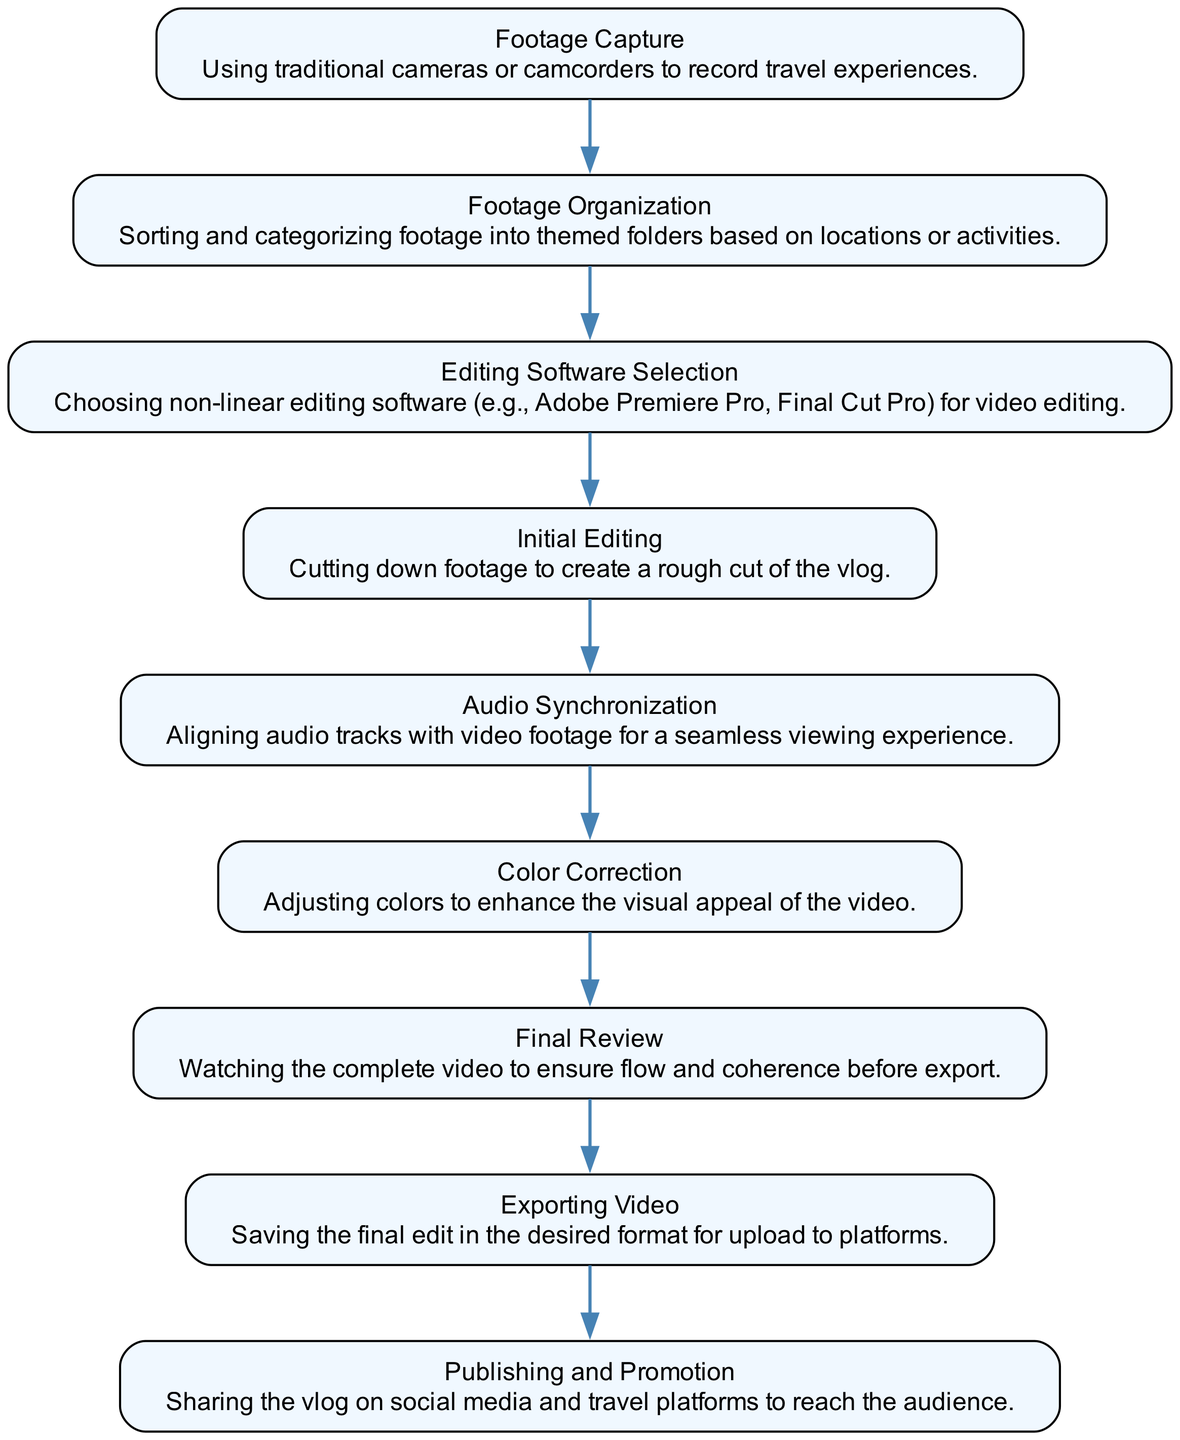What is the first step in the traditional editing process? The first step in the diagram is "Footage Capture," which indicates that recording travel experiences is the initial action taken.
Answer: Footage Capture How many main steps are there in the traditional editing process shown in the diagram? By counting each node within the diagram, we find that there are a total of nine main steps represented.
Answer: Nine Which step comes after "Initial Editing"? After "Initial Editing," the next step indicated in the flow is "Audio Synchronization," showing the sequential progression.
Answer: Audio Synchronization What type of software is selected in the editing process? The diagram specifies "non-linear editing software" as the type of software used, indicating a specific category of editing tools.
Answer: Non-linear editing software Which process is last before exporting the video? Before the video gets exported, the "Final Review" step takes place, highlighting the importance of ensuring quality and coherence.
Answer: Final Review What activity follows after the "Exporting Video" step? Following the exportation of the video, the "Publishing and Promotion" step occurs, emphasizing the sharing of the vlog with an audience.
Answer: Publishing and Promotion Which two steps focus on enhancing the video's quality? The steps "Color Correction" and "Audio Synchronization" both aim to enhance the overall quality of the video, addressing visual appeal and audio clarity.
Answer: Color Correction and Audio Synchronization What is the main purpose of the "Footage Organization" step? The purpose of "Footage Organization" is to sort and categorize footage into themed folders, facilitating easier access and editing during the process.
Answer: Sorting and categorizing footage What is the connection between "Editing Software Selection" and "Initial Editing"? "Editing Software Selection" precedes "Initial Editing," implying that the choice of software is foundational for starting the editing work.
Answer: Editing Software Selection leads to Initial Editing 